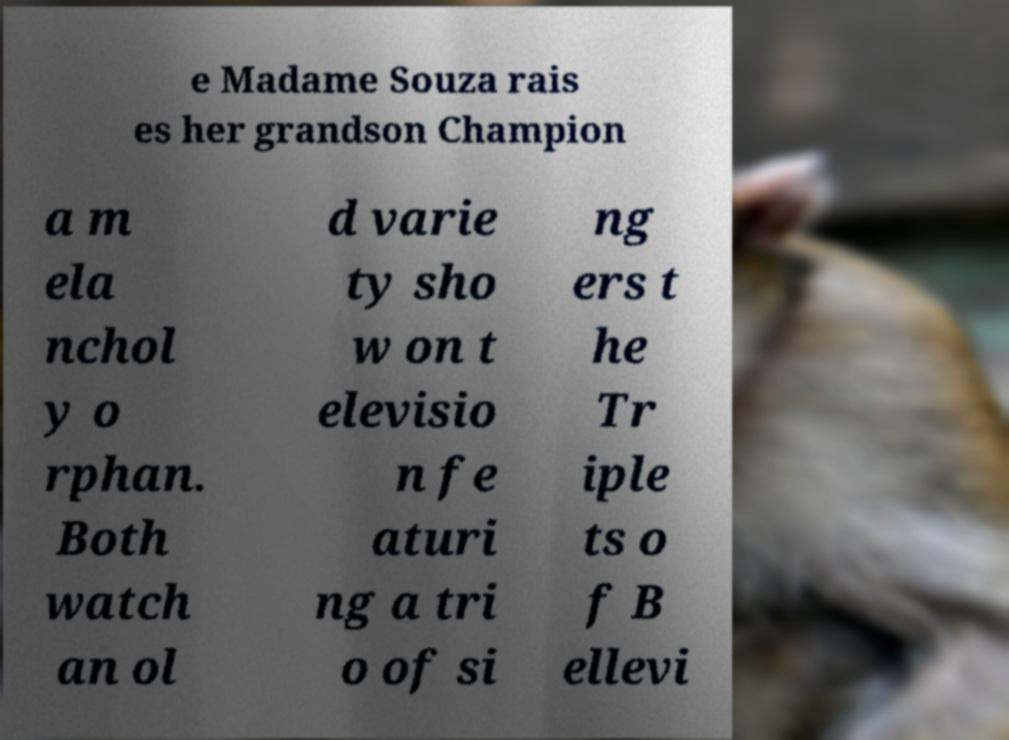Could you assist in decoding the text presented in this image and type it out clearly? e Madame Souza rais es her grandson Champion a m ela nchol y o rphan. Both watch an ol d varie ty sho w on t elevisio n fe aturi ng a tri o of si ng ers t he Tr iple ts o f B ellevi 